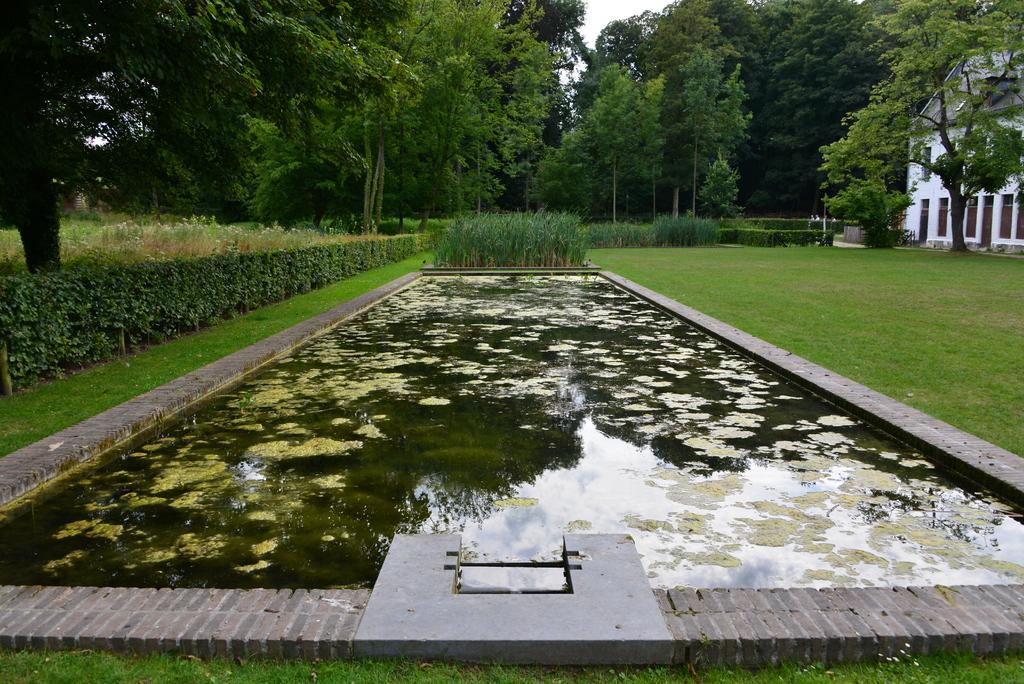Can you describe this image briefly? In this image I can see few trees,water,building,windows. The sky is in white color. 